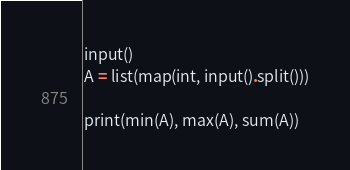<code> <loc_0><loc_0><loc_500><loc_500><_Python_>input()
A = list(map(int, input().split()))

print(min(A), max(A), sum(A))
</code> 